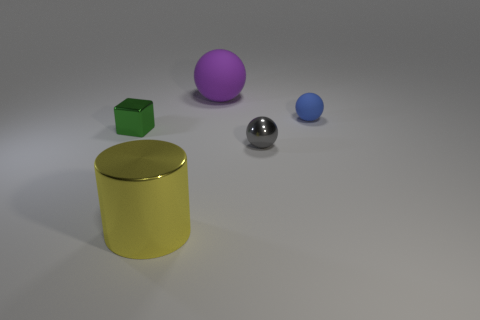Add 3 gray spheres. How many objects exist? 8 Subtract all blocks. How many objects are left? 4 Add 4 large yellow matte cylinders. How many large yellow matte cylinders exist? 4 Subtract 0 yellow cubes. How many objects are left? 5 Subtract all small red rubber blocks. Subtract all tiny matte things. How many objects are left? 4 Add 5 blue things. How many blue things are left? 6 